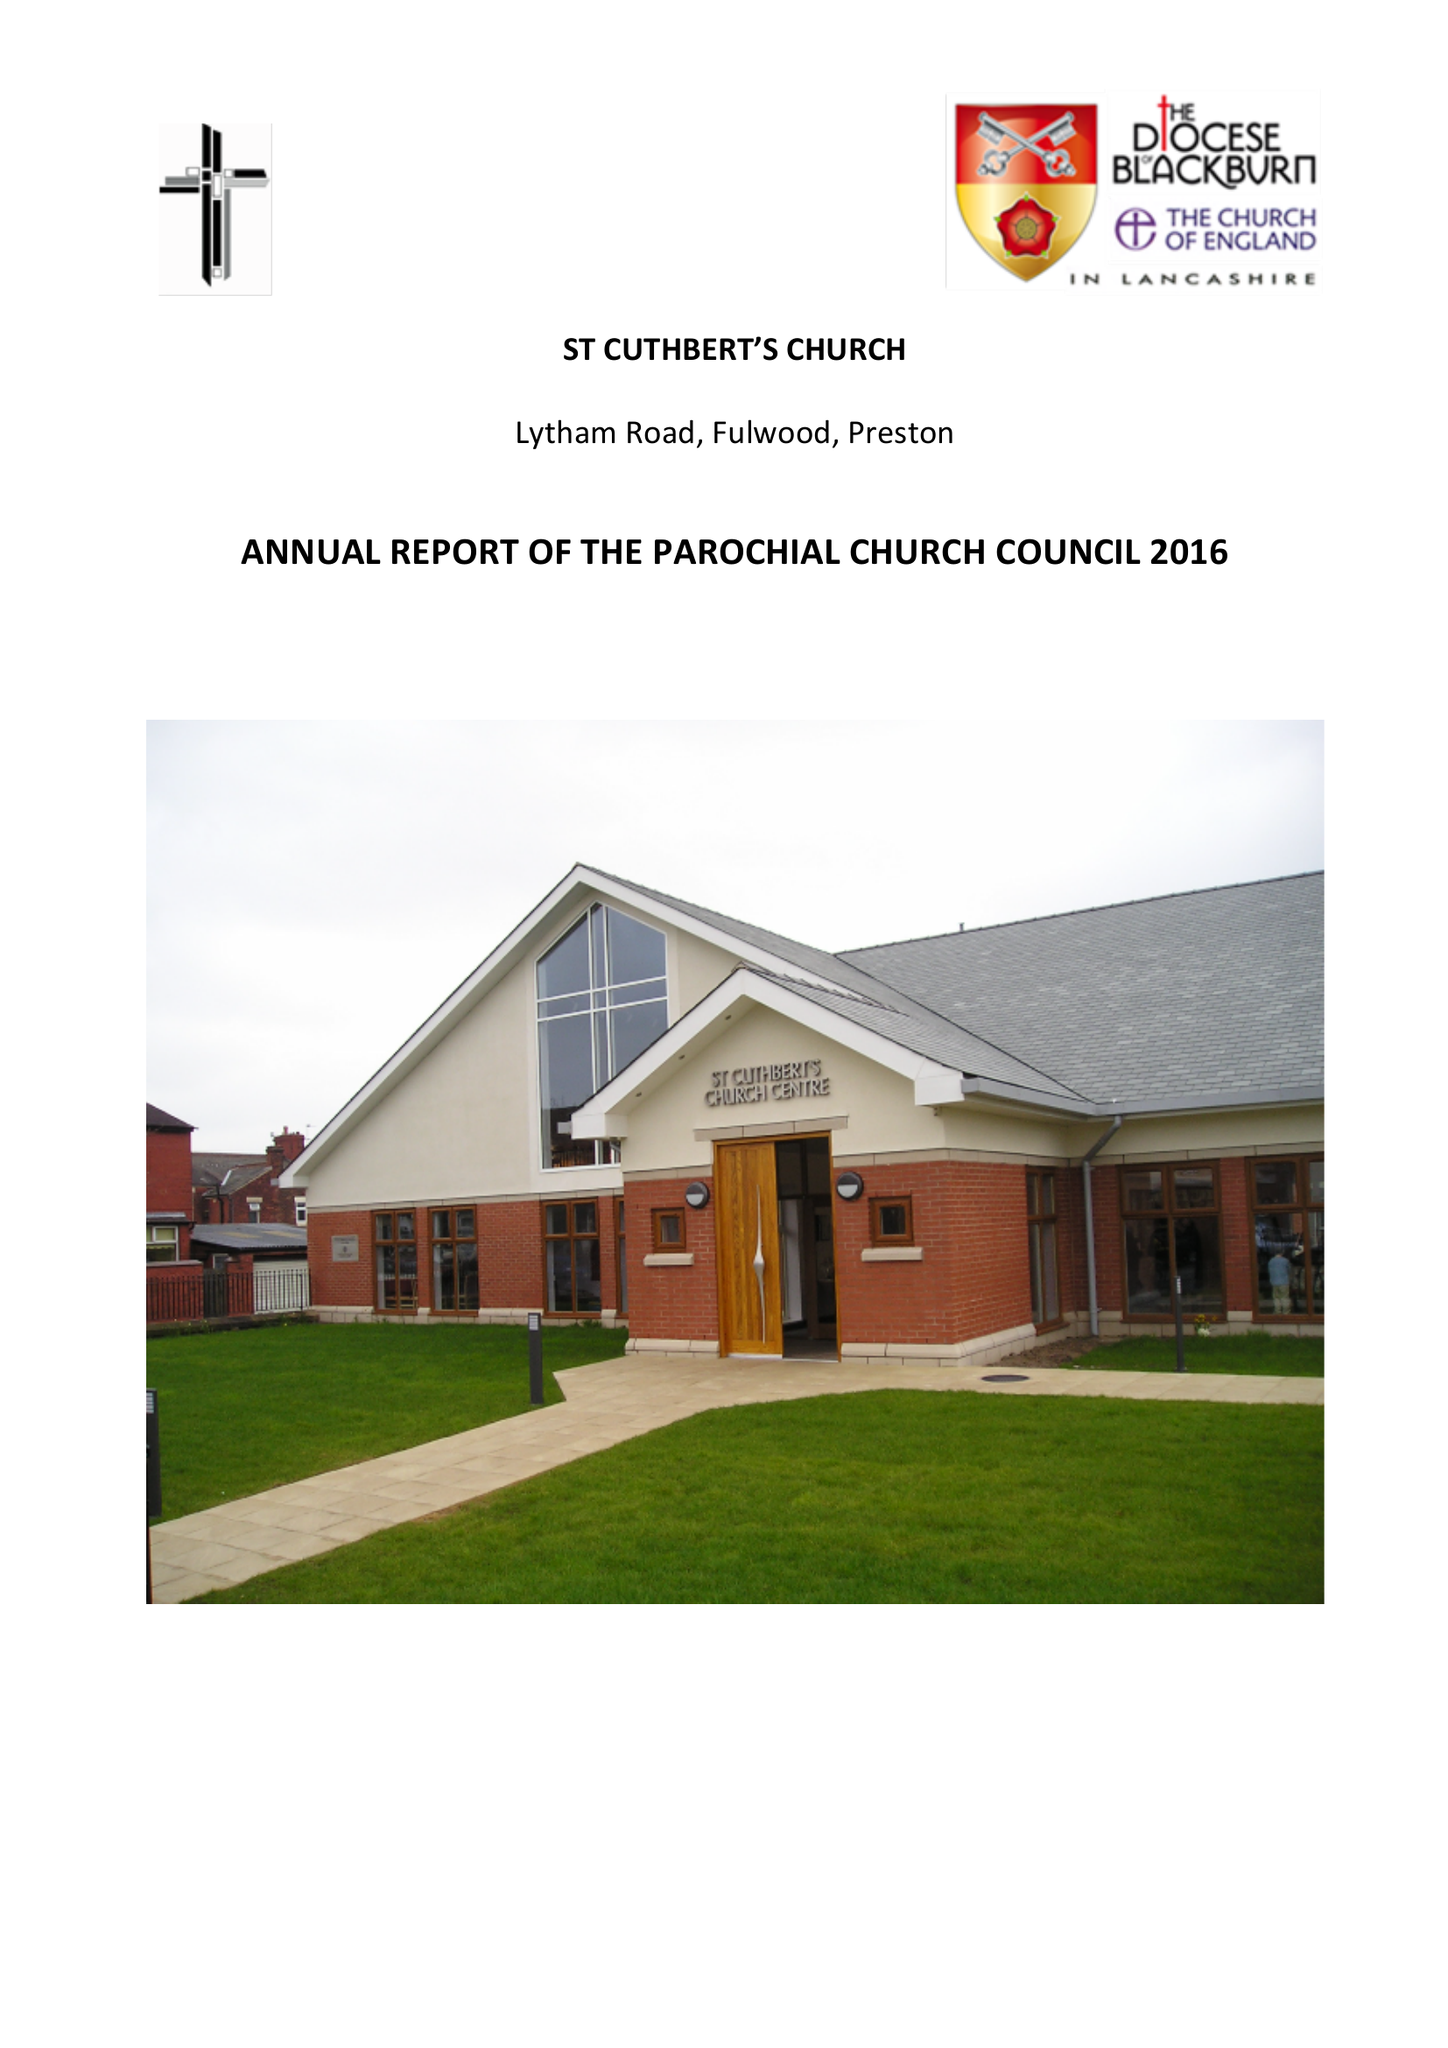What is the value for the charity_name?
Answer the question using a single word or phrase. The Parochial Church Council Of The Ecclesiastical Parish Of St Cuthberts, Fulwood 